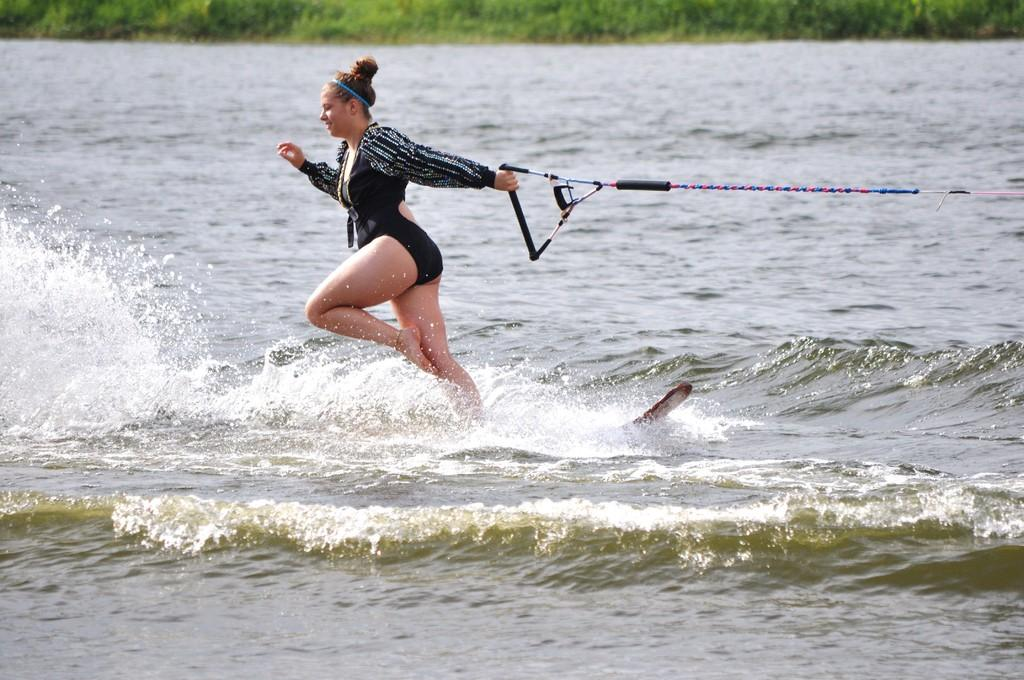Who is the main subject in the image? There is a woman in the image. What is the woman doing in the image? The woman is wakeboarding. What type of environment is the woman in? There is water in the image, suggesting a water-based environment. What can be seen in the background of the image? There are plants visible in the background of the image. What type of book is the woman reading while wakeboarding in the image? There is no book present in the image, as the woman is wakeboarding and not reading. 